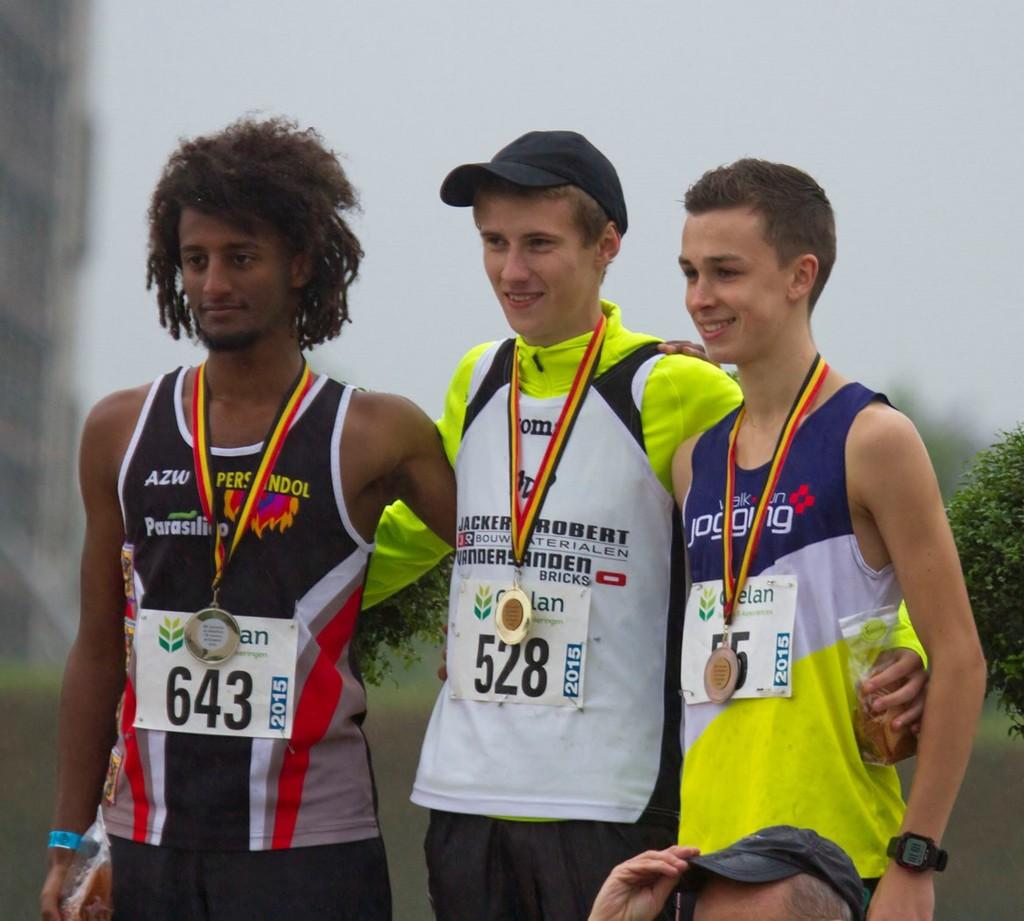What is the sport written on the man's shirt on the far right?
Keep it short and to the point. Jogging. What is the number of the man in the middle?
Provide a short and direct response. 528. 